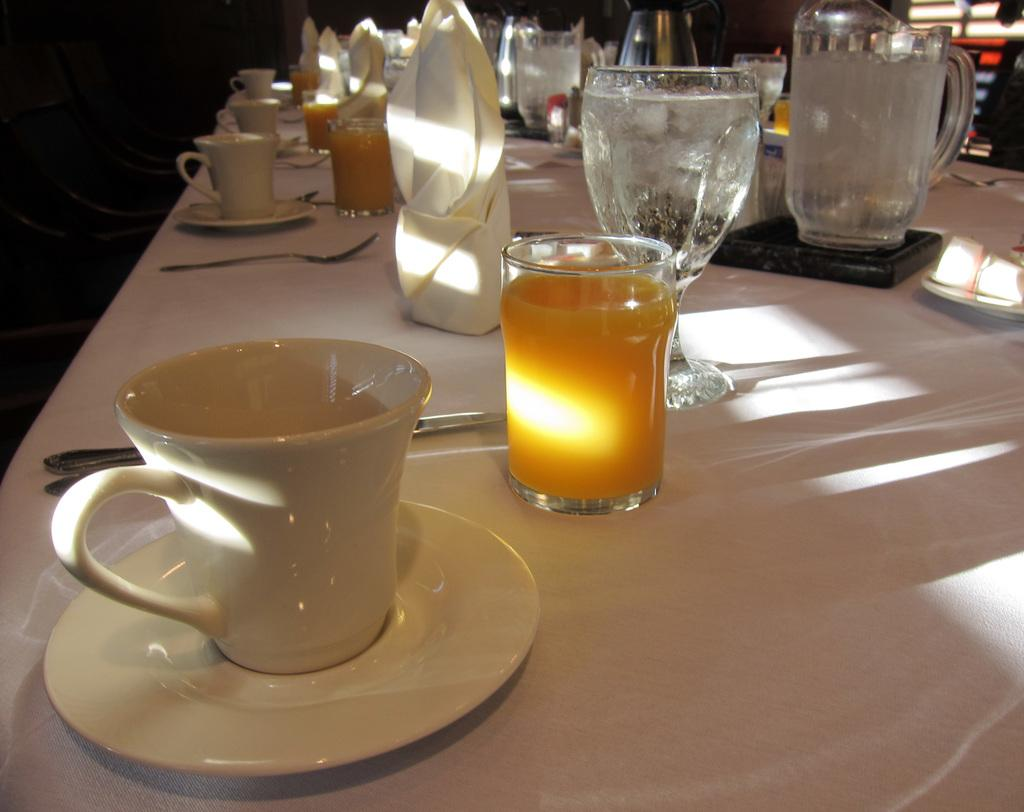What piece of furniture is present in the image? There is a table in the image. What items can be seen on the table? There is a cup and saucer, a glass with juice, a spoon, and a jar on the table. What might be used for drinking in the image? The glass with juice can be used for drinking. What might be used for stirring or eating in the image? The spoon can be used for stirring or eating. What type of ornament is hanging from the ceiling in the image? There is no ornament hanging from the ceiling in the image; it only features a table with various items on it. 